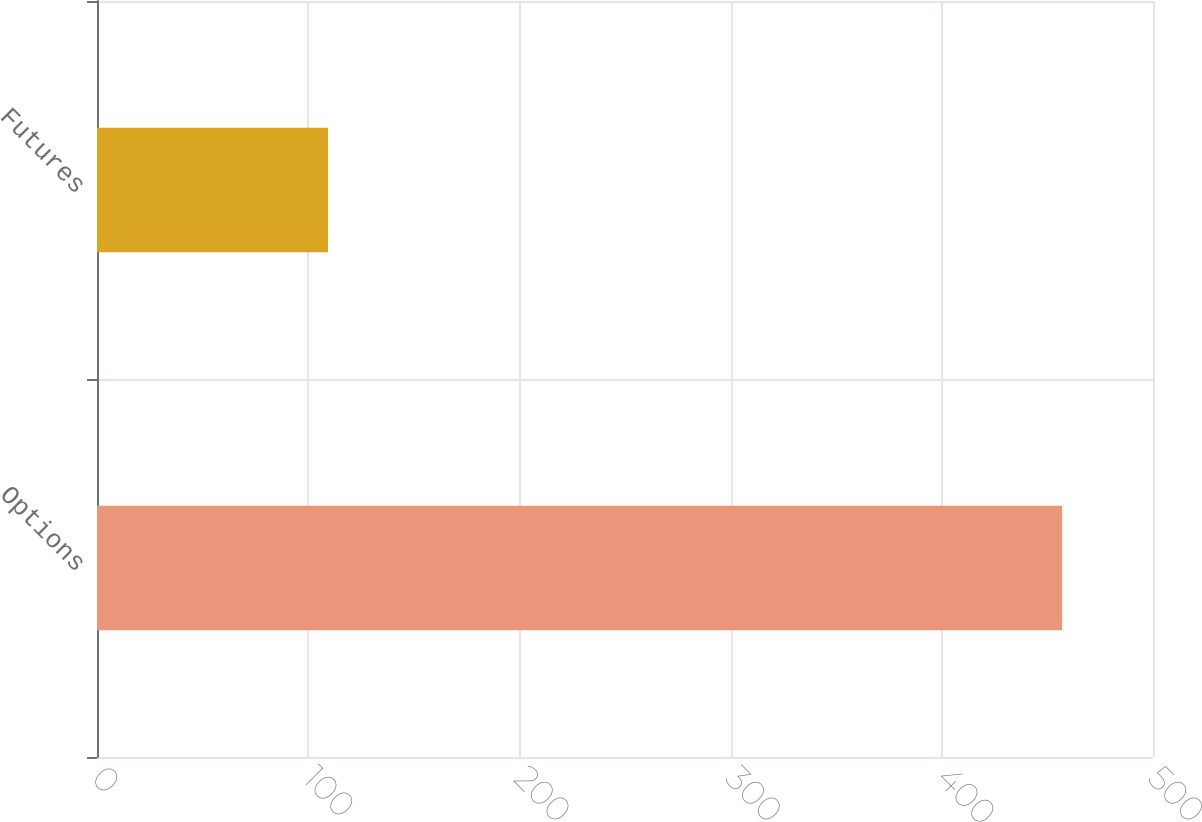Convert chart. <chart><loc_0><loc_0><loc_500><loc_500><bar_chart><fcel>Options<fcel>Futures<nl><fcel>457<fcel>109.4<nl></chart> 